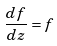Convert formula to latex. <formula><loc_0><loc_0><loc_500><loc_500>\frac { d f } { d z } = f</formula> 